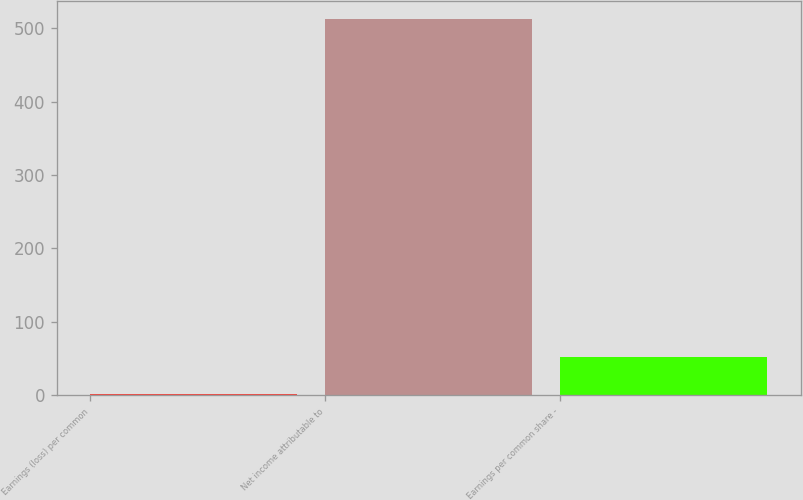Convert chart to OTSL. <chart><loc_0><loc_0><loc_500><loc_500><bar_chart><fcel>Earnings (loss) per common<fcel>Net income attributable to<fcel>Earnings per common share -<nl><fcel>1.18<fcel>512<fcel>52.26<nl></chart> 